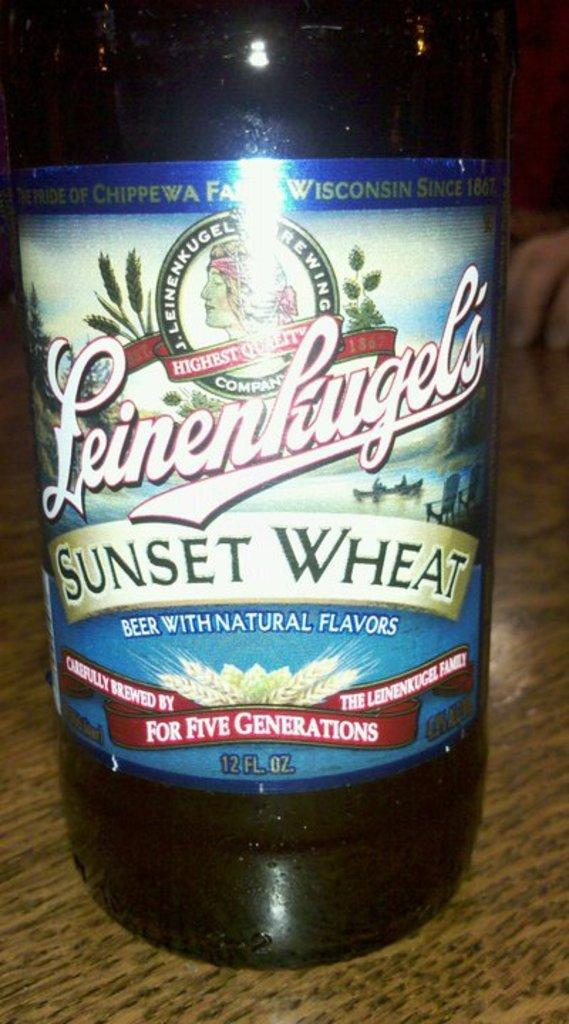<image>
Present a compact description of the photo's key features. Bottle of alcohol with a label that says "Sunset Wheat" on it. 